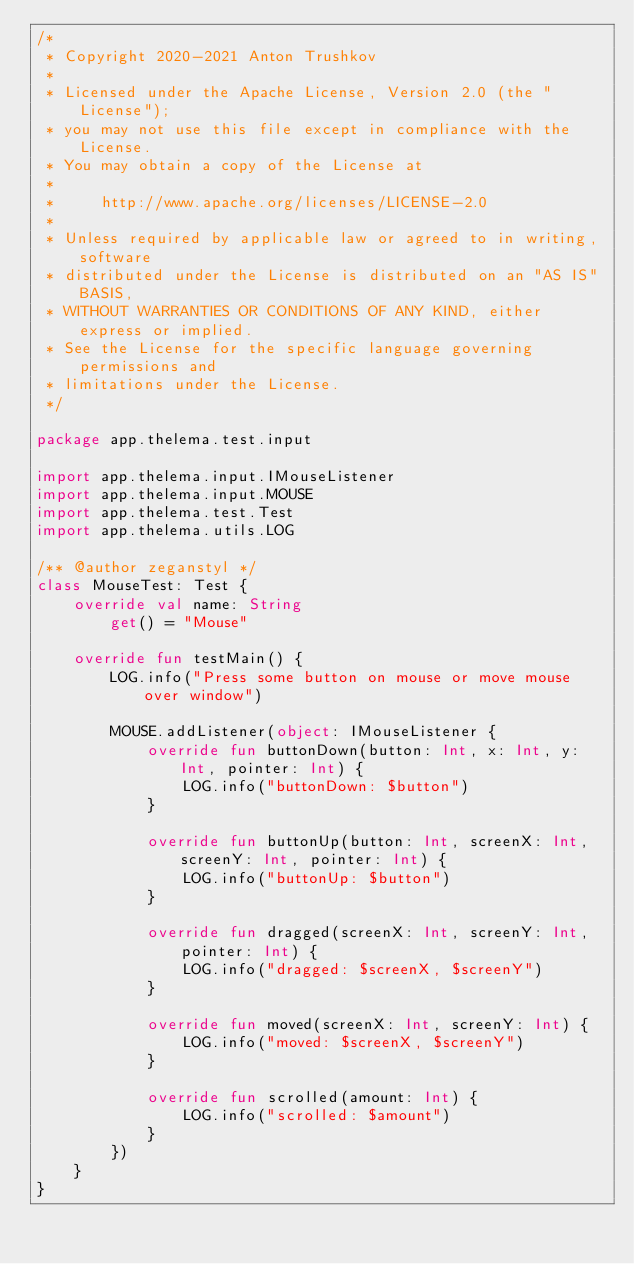<code> <loc_0><loc_0><loc_500><loc_500><_Kotlin_>/*
 * Copyright 2020-2021 Anton Trushkov
 *
 * Licensed under the Apache License, Version 2.0 (the "License");
 * you may not use this file except in compliance with the License.
 * You may obtain a copy of the License at
 *
 *     http://www.apache.org/licenses/LICENSE-2.0
 *
 * Unless required by applicable law or agreed to in writing, software
 * distributed under the License is distributed on an "AS IS" BASIS,
 * WITHOUT WARRANTIES OR CONDITIONS OF ANY KIND, either express or implied.
 * See the License for the specific language governing permissions and
 * limitations under the License.
 */

package app.thelema.test.input

import app.thelema.input.IMouseListener
import app.thelema.input.MOUSE
import app.thelema.test.Test
import app.thelema.utils.LOG

/** @author zeganstyl */
class MouseTest: Test {
    override val name: String
        get() = "Mouse"

    override fun testMain() {
        LOG.info("Press some button on mouse or move mouse over window")

        MOUSE.addListener(object: IMouseListener {
            override fun buttonDown(button: Int, x: Int, y: Int, pointer: Int) {
                LOG.info("buttonDown: $button")
            }

            override fun buttonUp(button: Int, screenX: Int, screenY: Int, pointer: Int) {
                LOG.info("buttonUp: $button")
            }

            override fun dragged(screenX: Int, screenY: Int, pointer: Int) {
                LOG.info("dragged: $screenX, $screenY")
            }

            override fun moved(screenX: Int, screenY: Int) {
                LOG.info("moved: $screenX, $screenY")
            }

            override fun scrolled(amount: Int) {
                LOG.info("scrolled: $amount")
            }
        })
    }
}
</code> 